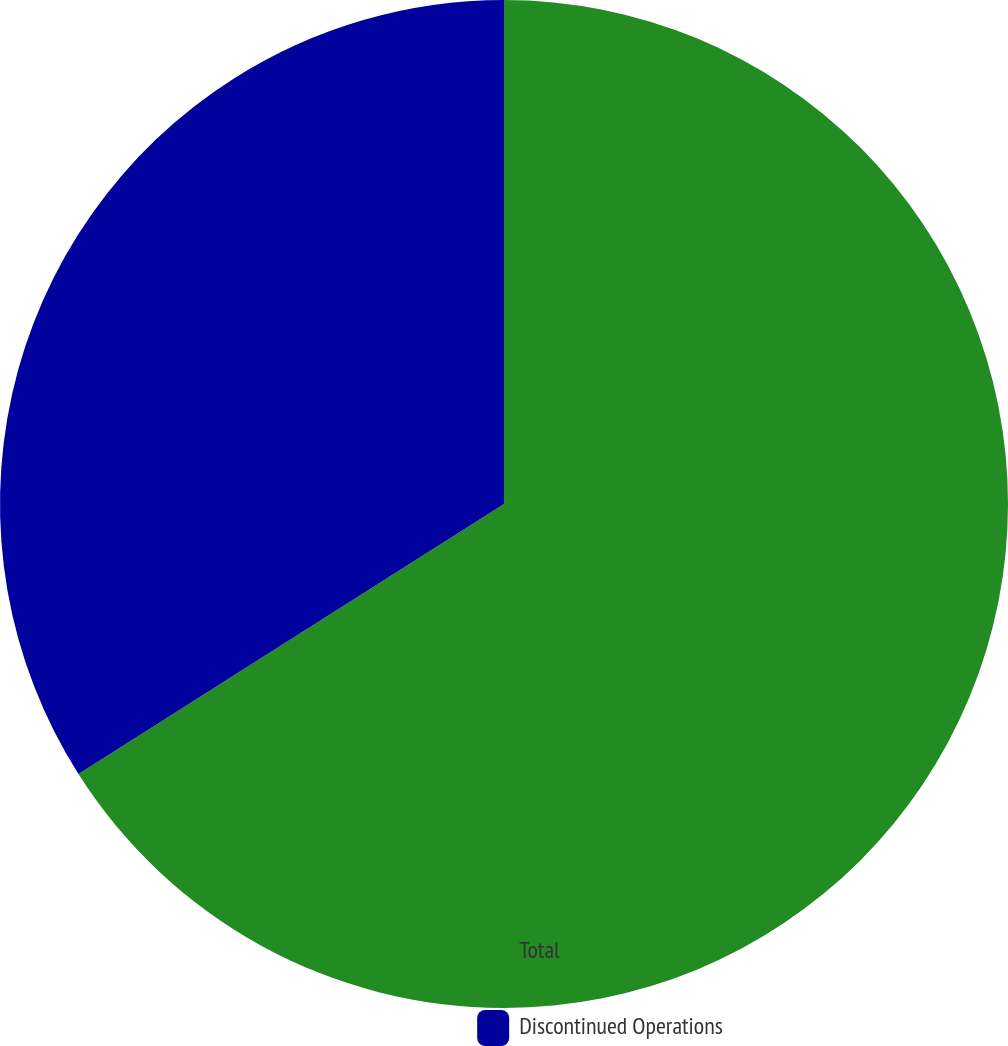<chart> <loc_0><loc_0><loc_500><loc_500><pie_chart><fcel>Total<fcel>Discontinued Operations<nl><fcel>66.0%<fcel>34.0%<nl></chart> 